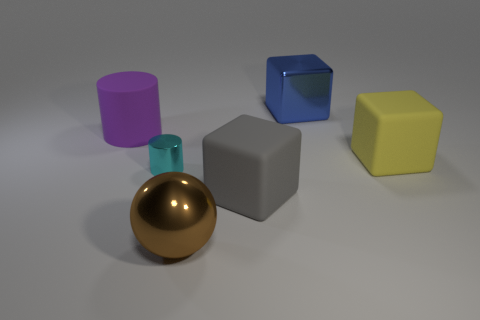There is a large rubber object that is in front of the big matte block that is behind the shiny cylinder; what shape is it?
Your answer should be very brief. Cube. How many cylinders have the same material as the gray block?
Offer a very short reply. 1. There is a cube that is the same material as the small object; what is its color?
Give a very brief answer. Blue. What is the size of the cube behind the matte cube that is behind the matte thing that is in front of the yellow cube?
Ensure brevity in your answer.  Large. Is the number of purple objects less than the number of tiny green rubber cubes?
Give a very brief answer. No. What color is the large object that is the same shape as the tiny metal object?
Keep it short and to the point. Purple. There is a object behind the rubber thing that is on the left side of the tiny cyan metallic cylinder; are there any large purple rubber things on the left side of it?
Ensure brevity in your answer.  Yes. Is the shape of the large gray matte thing the same as the small metallic object?
Keep it short and to the point. No. Are there fewer big yellow things behind the large rubber cylinder than yellow things?
Your answer should be compact. Yes. What is the color of the big metal object right of the large metal thing that is in front of the tiny object behind the brown object?
Offer a terse response. Blue. 